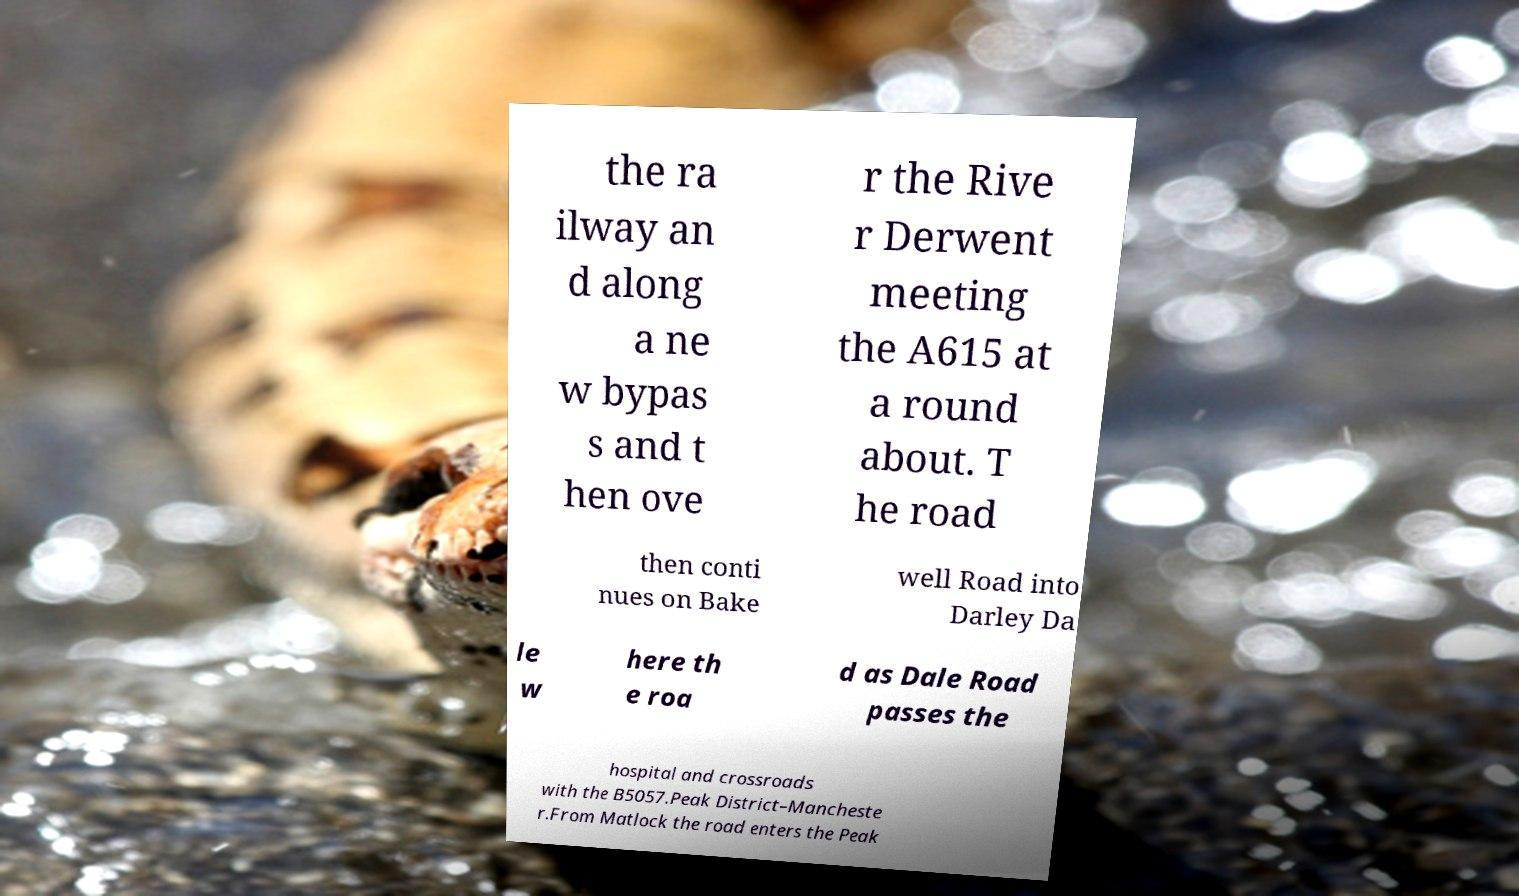Could you assist in decoding the text presented in this image and type it out clearly? the ra ilway an d along a ne w bypas s and t hen ove r the Rive r Derwent meeting the A615 at a round about. T he road then conti nues on Bake well Road into Darley Da le w here th e roa d as Dale Road passes the hospital and crossroads with the B5057.Peak District–Mancheste r.From Matlock the road enters the Peak 